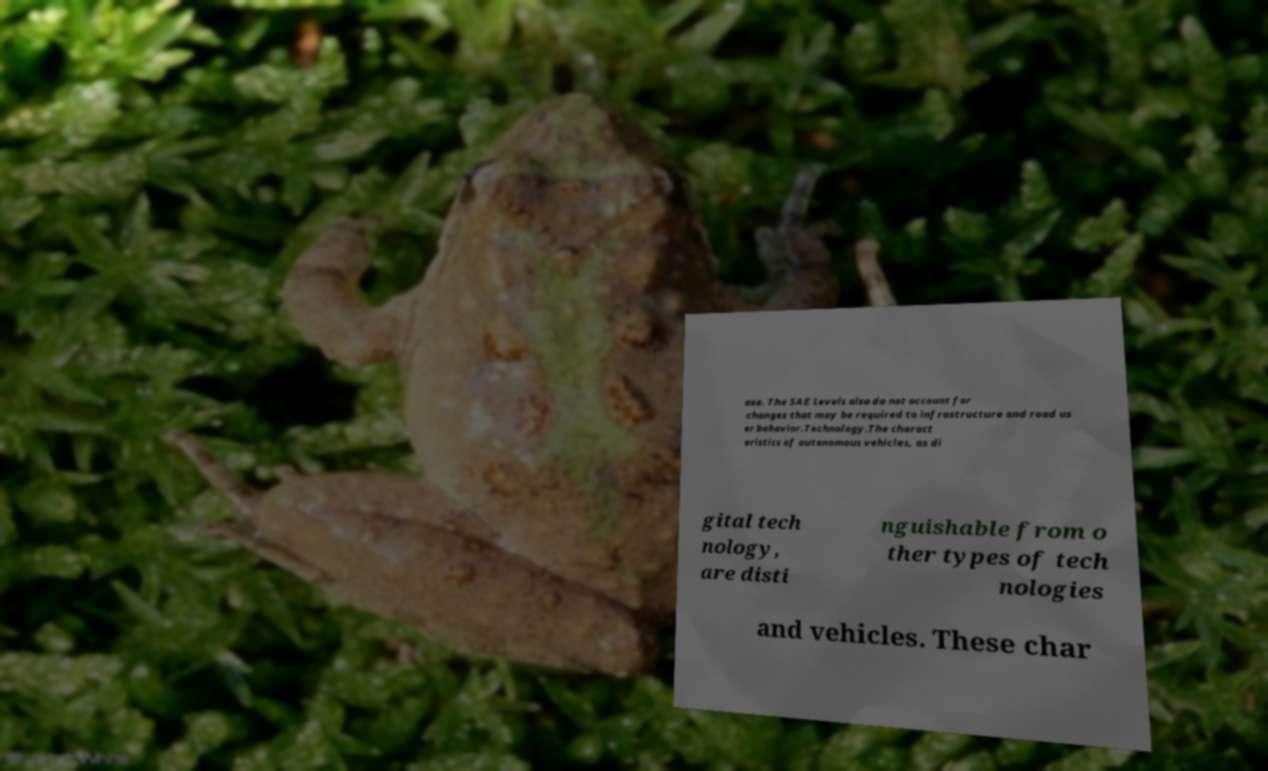What messages or text are displayed in this image? I need them in a readable, typed format. ase. The SAE Levels also do not account for changes that may be required to infrastructure and road us er behavior.Technology.The charact eristics of autonomous vehicles, as di gital tech nology, are disti nguishable from o ther types of tech nologies and vehicles. These char 